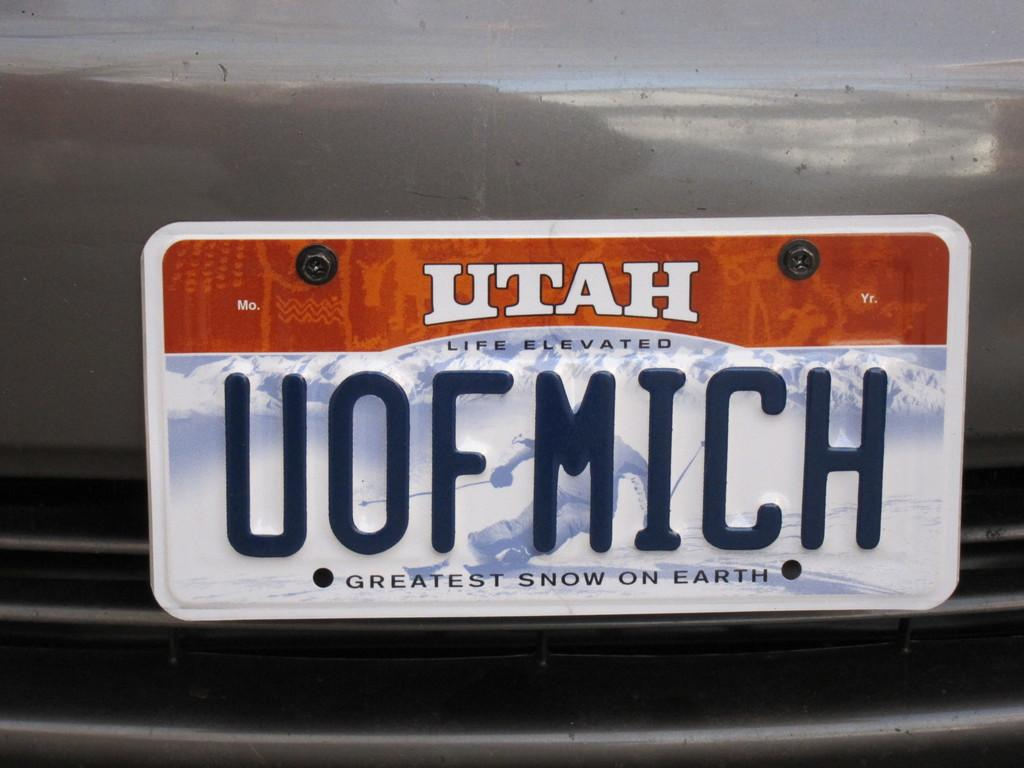Provide a one-sentence caption for the provided image. A car licence plate with the word Utah on it . 